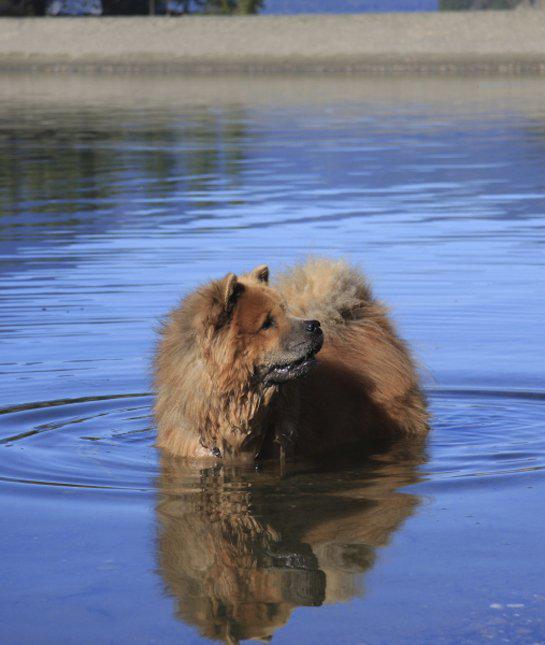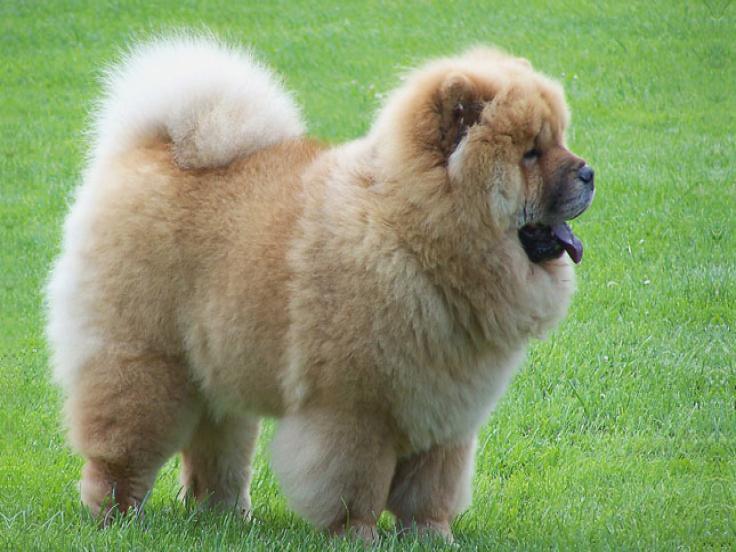The first image is the image on the left, the second image is the image on the right. Given the left and right images, does the statement "There are four dogs in total." hold true? Answer yes or no. No. The first image is the image on the left, the second image is the image on the right. For the images displayed, is the sentence "There are puppies in each image." factually correct? Answer yes or no. No. 